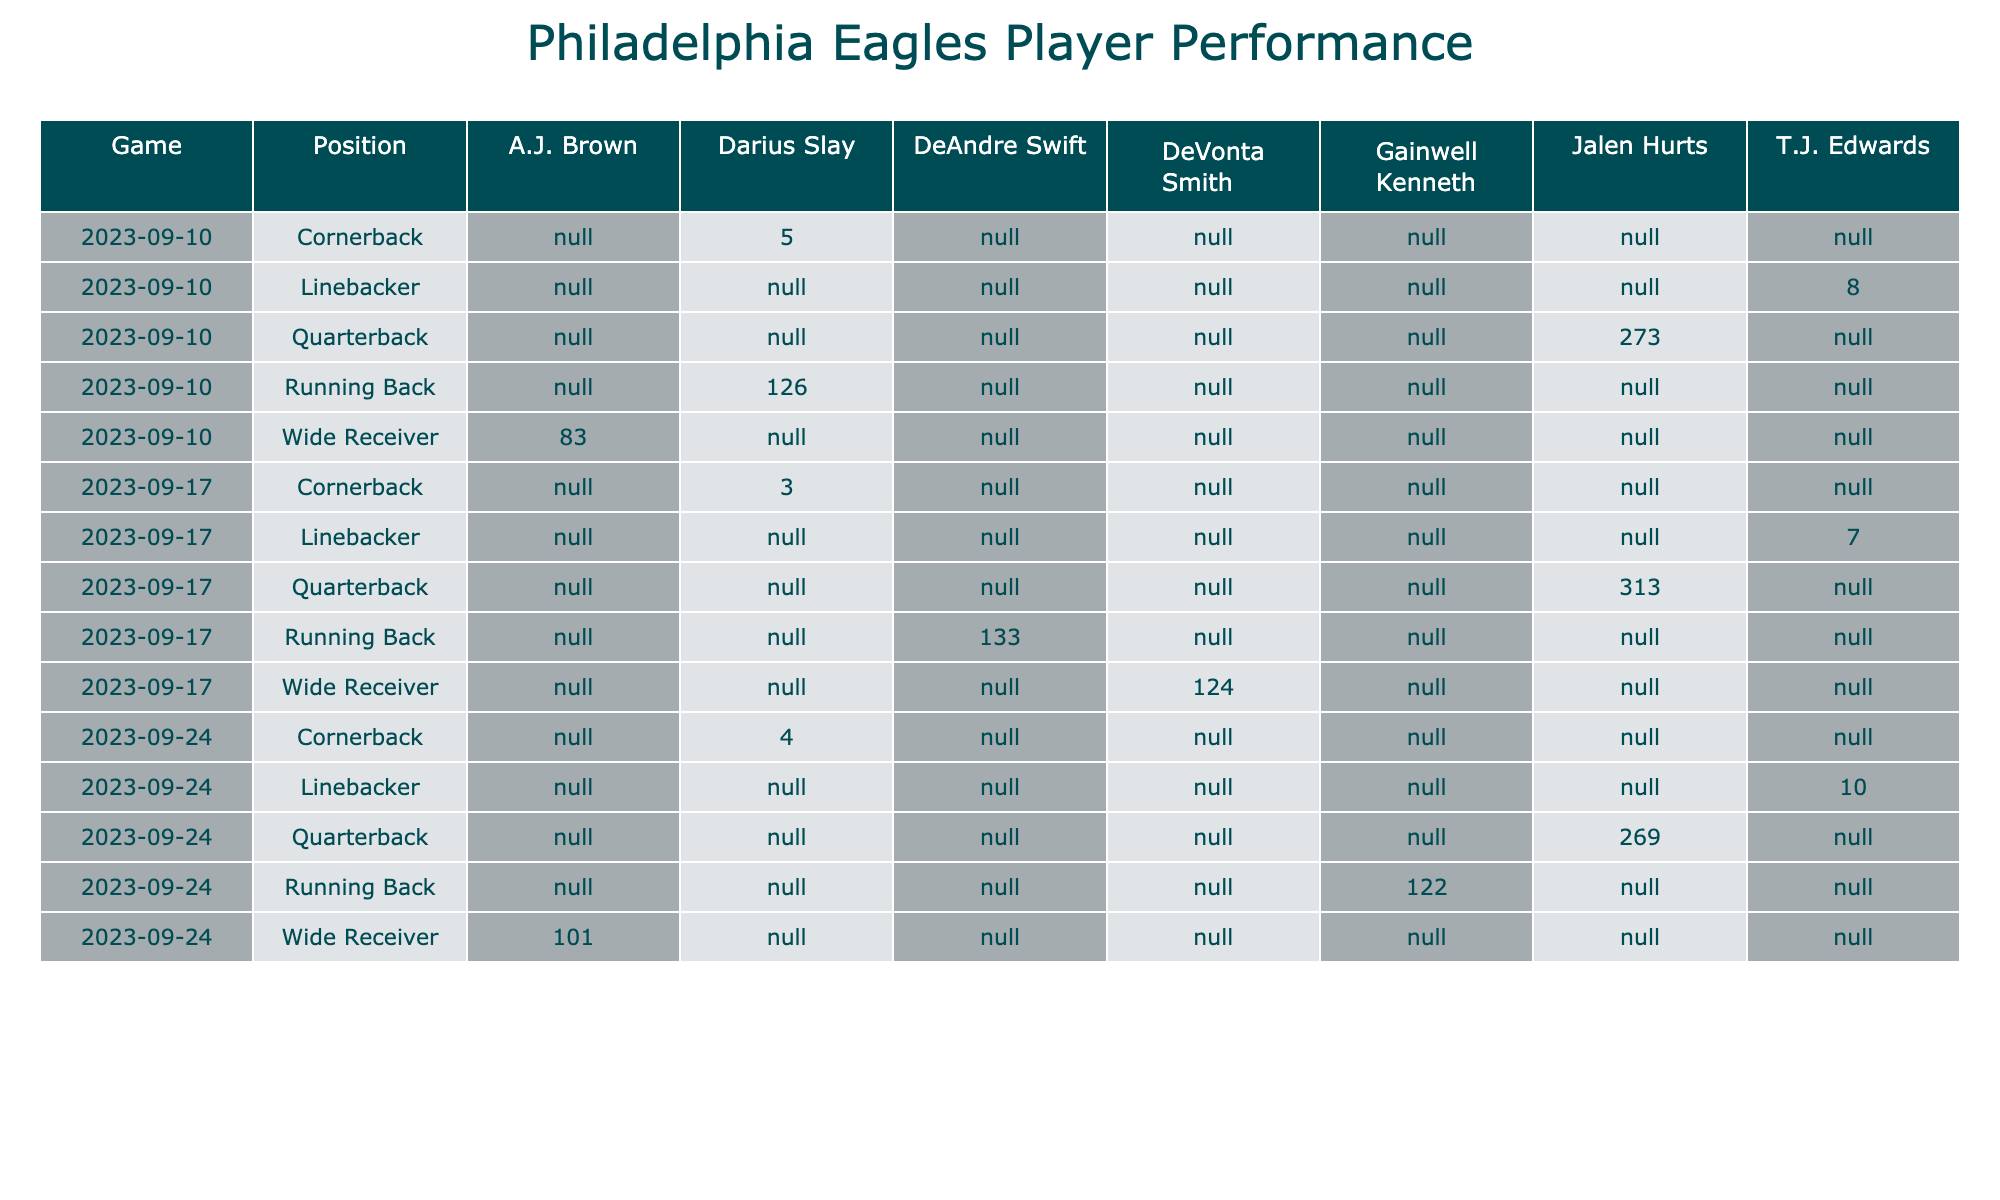What is the total number of touchdowns scored by Jalen Hurts? In the table, I can see that Jalen Hurts scored touchdowns in two games: 2 touchdowns in the first game (2023-09-10) and 0 touchdowns in the second game (2023-09-17). Summing these gives 2 + 0 = 2.
Answer: 2 Which player recorded the highest passing yards in the game on 2023-09-17? Reviewing the data for the game on 2023-09-17, Jalen Hurts had 280 passing yards, which is higher than any other player in that game.
Answer: Jalen Hurts Did Darius Slay score any touchdowns in the games listed? By looking at the table, Darius Slay has 0 touchdowns in all games listed, indicated in all rows where his name appears.
Answer: No What is the average total yardage (passing, rushing, receiving) for the running backs in the game on 2023-09-24? For the game on 2023-09-24, the data shows Gainwell Kenneth with passing yards (0) + rushing yards (75) + receiving yards (0) = 75 total yards. Since there is only one running back on that date, the average is also 75.
Answer: 75 Which player had the most total yards (including passing, rushing, receiving, tackles, interceptions, touchdowns) in the game on 2023-09-10? In the game on 2023-09-10, summing up the total yardage for each player: Jalen Hurts = 250 + 20 + 0 + 0 + 1 + 2 = 273, Darius Slay = 30 + 90 + 0 + 5 + 0 + 1 = 126, A.J. Brown = 2 + 0 + 80 + 0 + 0 + 1 = 83, T.J. Edwards = 0 + 0 + 0 + 8 + 0 + 0 = 8, Darius Slay (cornerback) = 0 + 0 + 0 + 4 + 1 + 0 = 5. The highest is Jalen Hurts with 273.
Answer: Jalen Hurts 